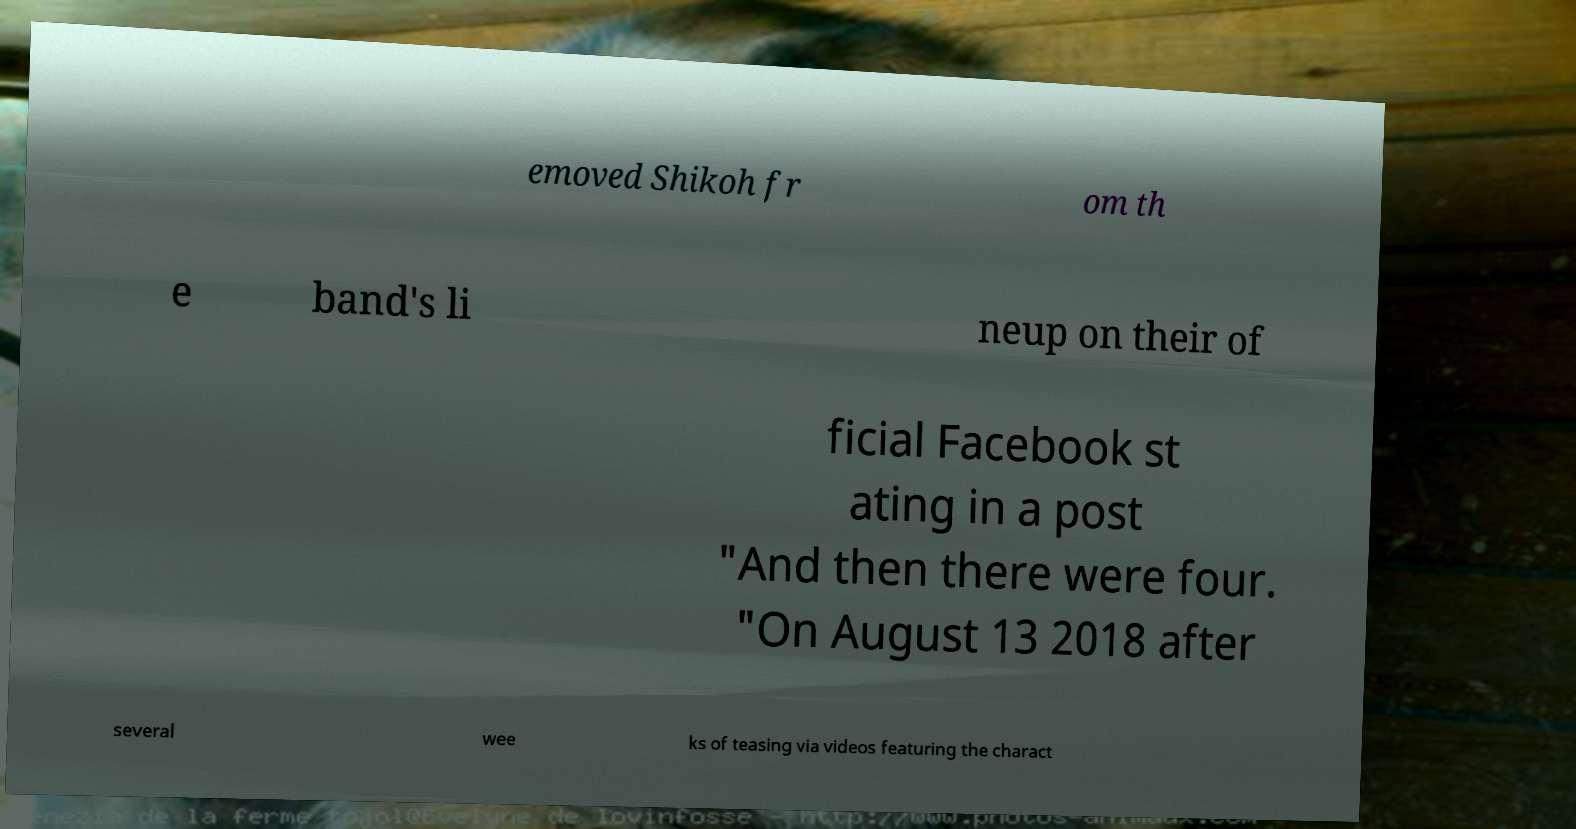For documentation purposes, I need the text within this image transcribed. Could you provide that? emoved Shikoh fr om th e band's li neup on their of ficial Facebook st ating in a post "And then there were four. "On August 13 2018 after several wee ks of teasing via videos featuring the charact 